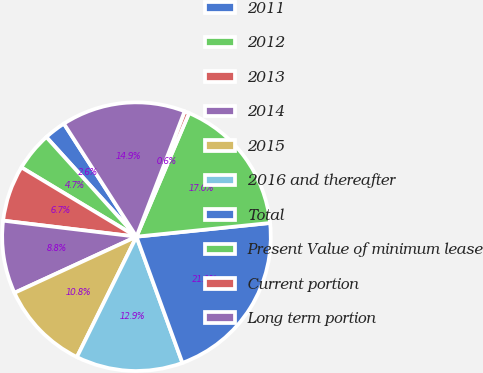Convert chart to OTSL. <chart><loc_0><loc_0><loc_500><loc_500><pie_chart><fcel>2011<fcel>2012<fcel>2013<fcel>2014<fcel>2015<fcel>2016 and thereafter<fcel>Total<fcel>Present Value of minimum lease<fcel>Current portion<fcel>Long term portion<nl><fcel>2.62%<fcel>4.67%<fcel>6.72%<fcel>8.77%<fcel>10.82%<fcel>12.87%<fcel>21.07%<fcel>16.97%<fcel>0.57%<fcel>14.92%<nl></chart> 